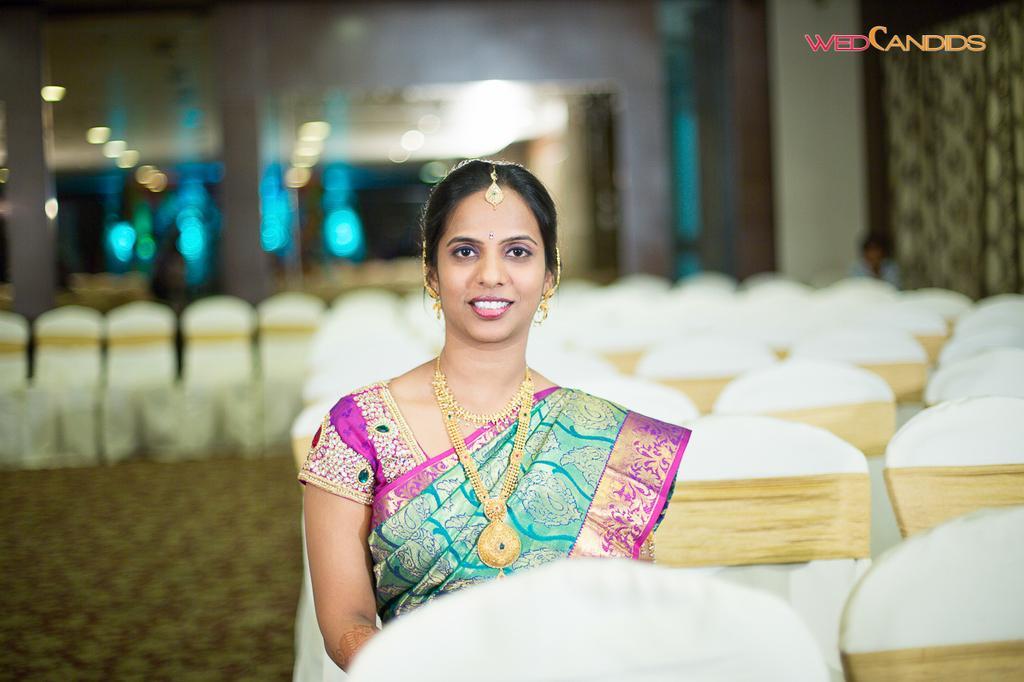Please provide a concise description of this image. In the image there is a bride groom sitting on chair in saree and jewels and in the back there are many chairs. 